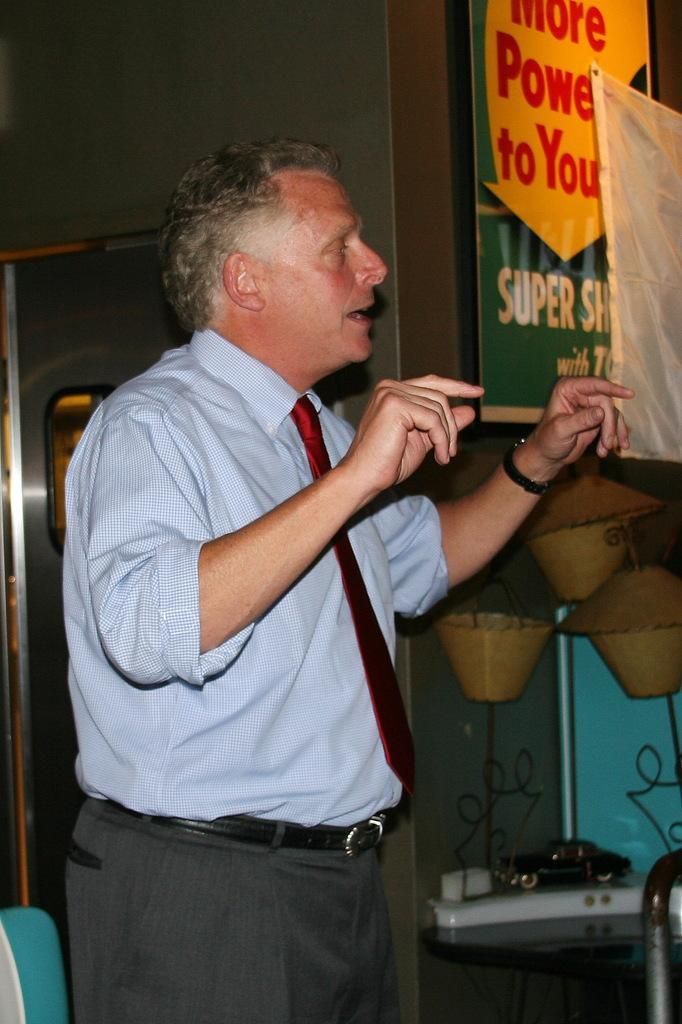<image>
Relay a brief, clear account of the picture shown. A man speaks whilst on the wall behind him a sign reads More Power to You 